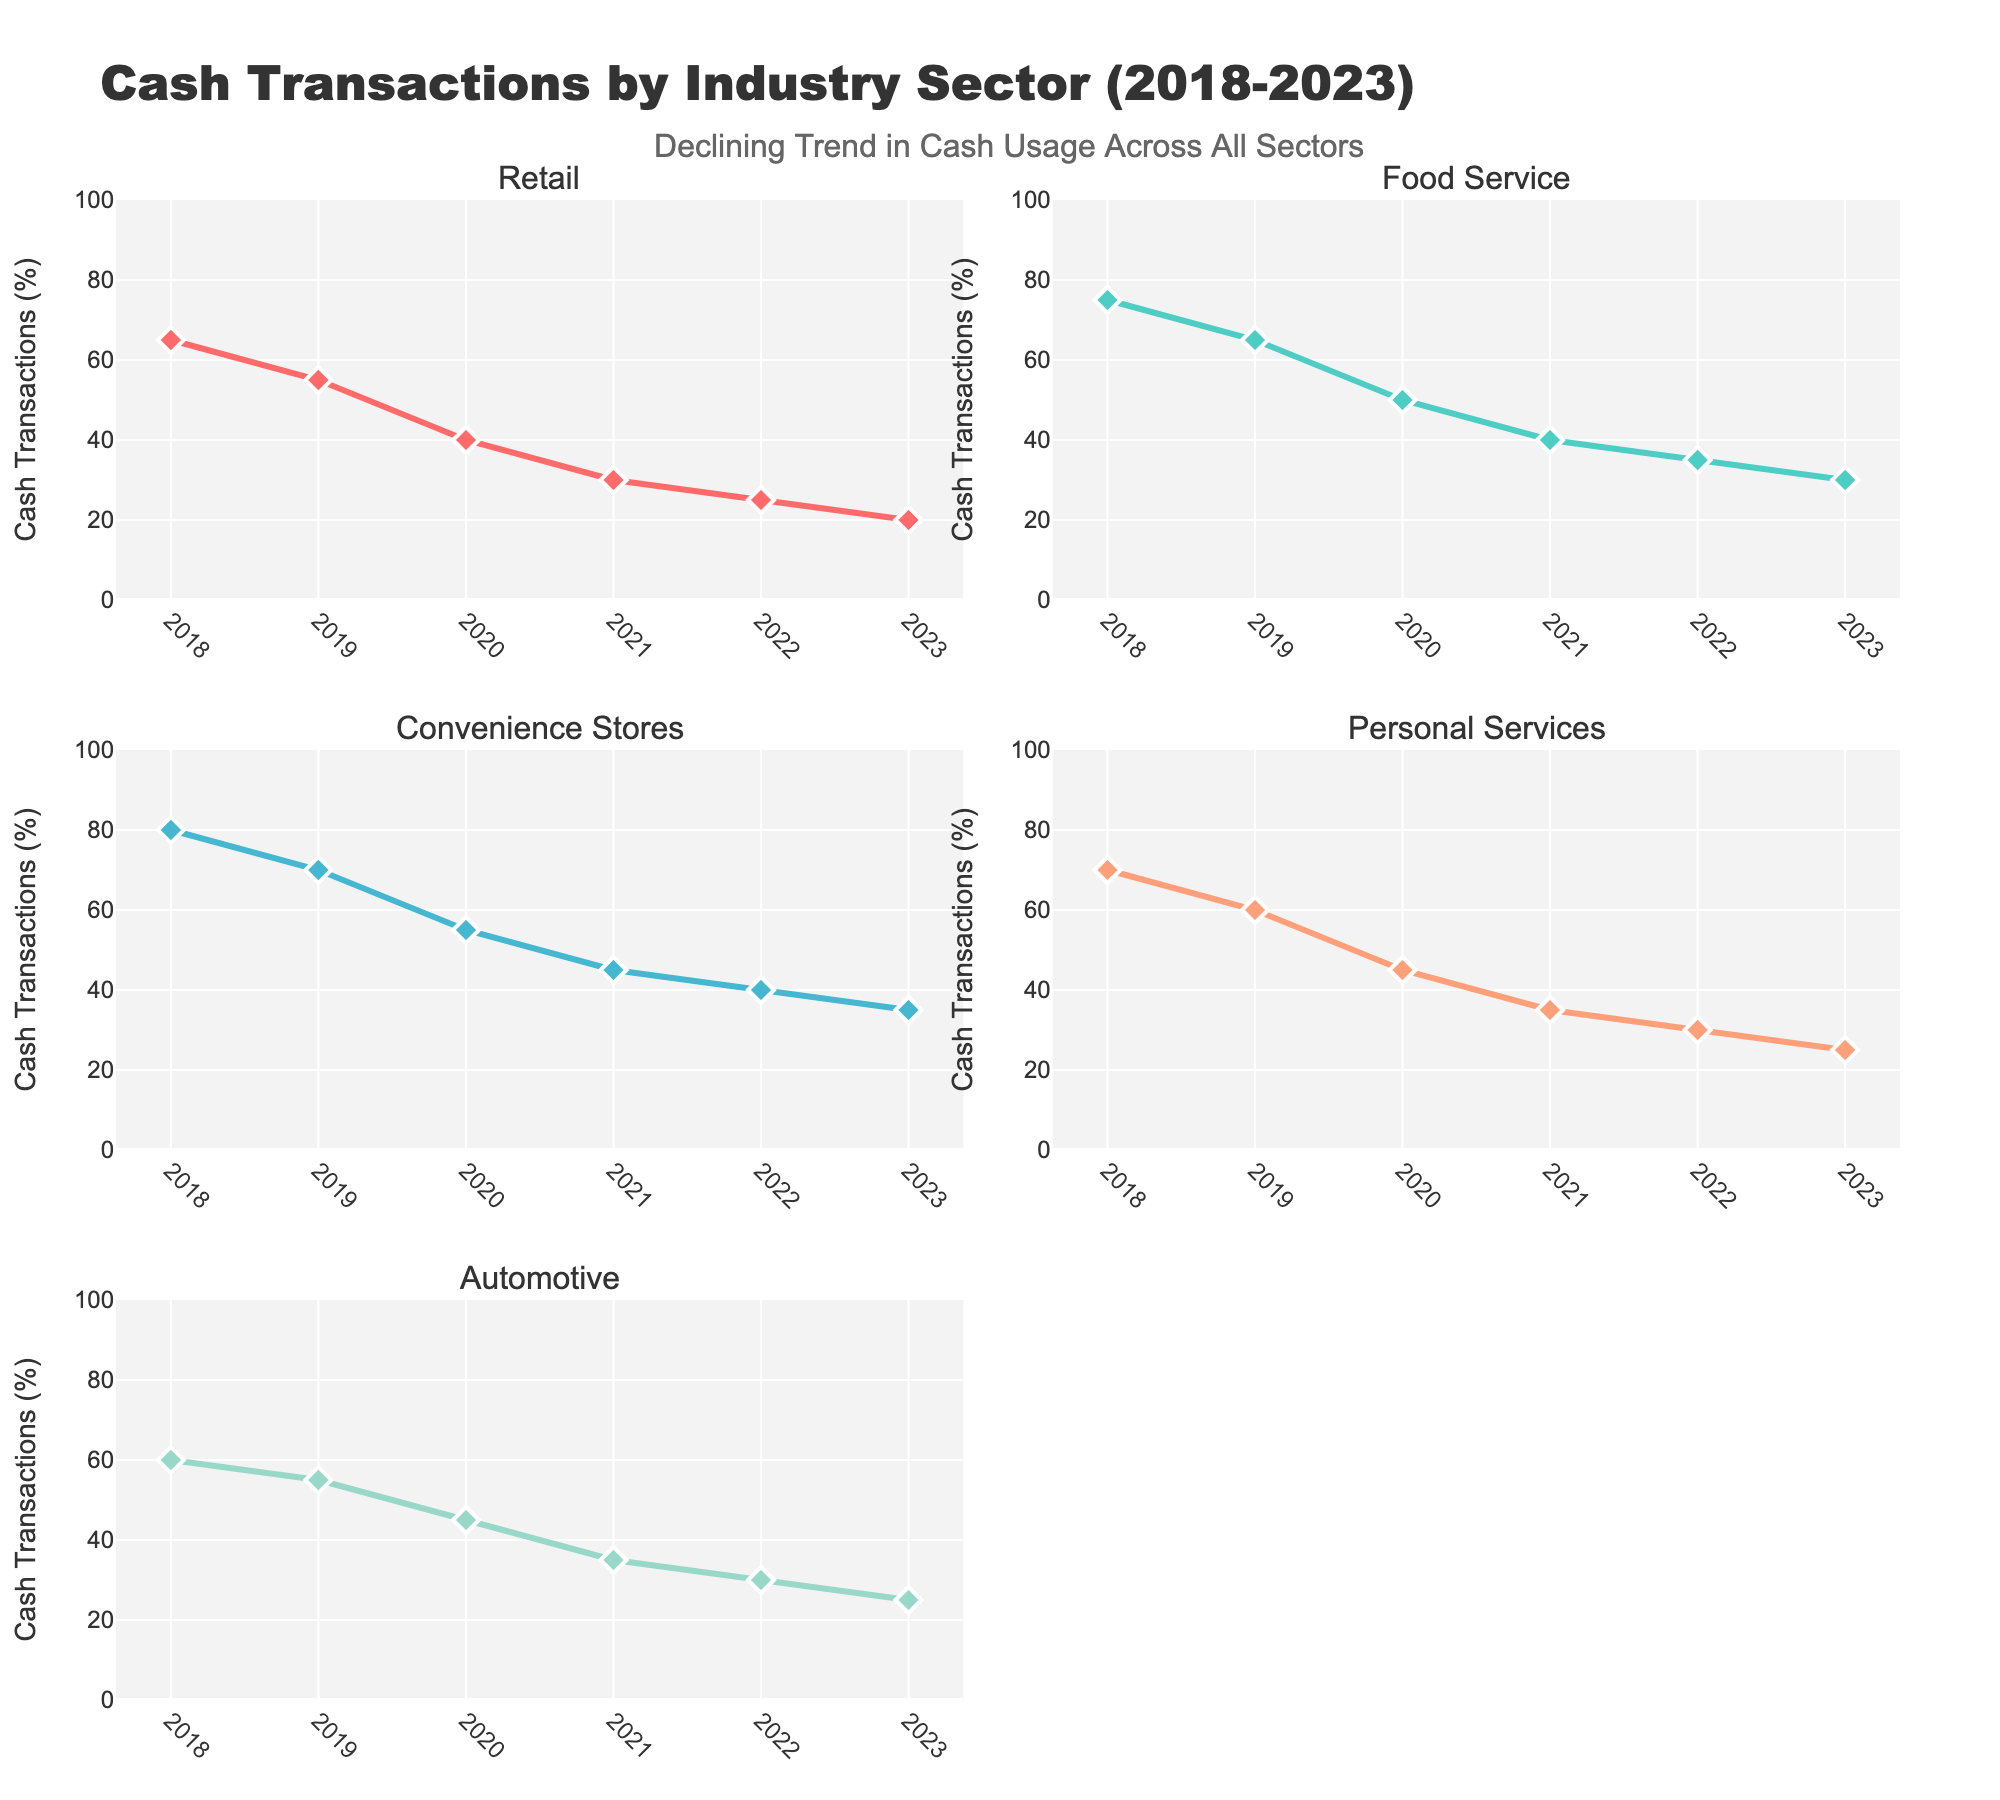What title is displayed at the top of the figure? The title is displayed prominently at the top of the figure and reads "Cash Transactions by Industry Sector (2018-2023)". It is in a large, bold font to draw attention to the main topic.
Answer: Cash Transactions by Industry Sector (2018-2023) What is the general trend in cash transactions across all industries from 2018 to 2023? By observing the lines for each industry, we can see that the percentage of cash transactions decreases steadily over the years from 2018 to 2023. Each line slopes downward from left to right, indicating a decline in cash usage.
Answer: Declining What was the percentage of cash transactions in Convenience Stores in 2020? Look at the subplot for Convenience Stores and find the point corresponding to the year 2020. The y-axis value at this point is 55%.
Answer: 55% In which year did Personal Services first have less than 40% cash transactions? Observe the Personal Services subplot and the points on the line. The first year the line drops below 40% is in 2021.
Answer: 2021 Which industry had the highest percentage of cash transactions in 2018? Compare the y-values of all the subplots for the year 2018. Convenience Stores has the highest percentage at 80%.
Answer: Convenience Stores What is the difference in cash transactions between Retail and Automotive sectors in 2023? Find the y-values for Retail and Automotive in 2023, which are 20% and 25% respectively. Subtract the smaller percentage from the larger one: 25% - 20% = 5%.
Answer: 5% Between which consecutive years did Food Service see the largest drop in cash transactions? Calculate the year-to-year differences in the Food Service subplot: 2018-2019 (75%-65%=10%), 2019-2020 (65%-50%=15%), 2020-2021 (50%-40%=10%), 2021-2022 (40%-35%=5%), 2022-2023 (35%-30%=5%). The largest drop is between 2019 and 2020 with a 15% decrease.
Answer: 2019 and 2020 In 2021, which industries had similar percentages of cash transactions? Compare the y-values for each industry in 2021 from their respective subplots: Retail (30%), Food Service (40%), Convenience Stores (45%), Personal Services (35%), Automotive (35%). Personal Services and Automotive both have 35%.
Answer: Personal Services and Automotive What was the average percentage of cash transactions in Retail from 2018 to 2023? Add the Retail percentages and divide by the number of years: (65 + 55 + 40 + 30 + 25 + 20) / 6 = 235 / 6 ≈ 39.17%.
Answer: 39.17% Which industry experienced the smallest decline in cash transactions from 2018 to 2023? Calculate the decline for each industry by subtracting 2023 percentages from 2018 percentages: Retail (65-20 = 45), Food Service (75-30 = 45), Convenience Stores (80-35 = 45), Personal Services (70-25 = 45), Automotive (60-25 = 35). Automotive experienced the smallest decline with 35%.
Answer: Automotive 